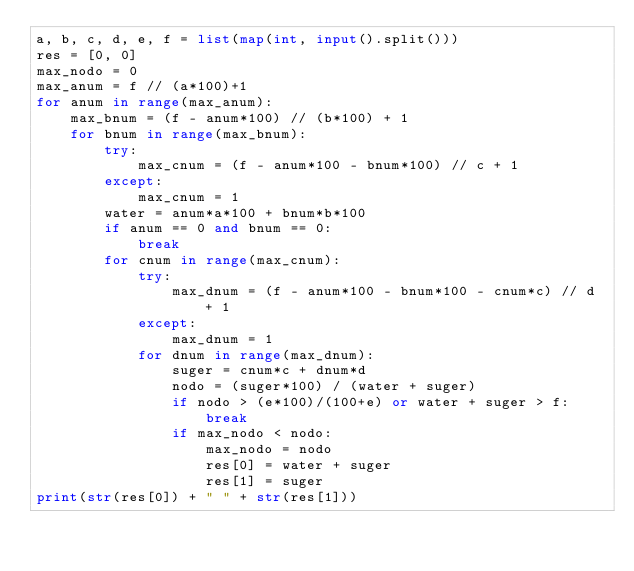Convert code to text. <code><loc_0><loc_0><loc_500><loc_500><_Python_>a, b, c, d, e, f = list(map(int, input().split()))
res = [0, 0]
max_nodo = 0
max_anum = f // (a*100)+1
for anum in range(max_anum):
    max_bnum = (f - anum*100) // (b*100) + 1
    for bnum in range(max_bnum):
        try:
            max_cnum = (f - anum*100 - bnum*100) // c + 1
        except:
            max_cnum = 1
        water = anum*a*100 + bnum*b*100
        if anum == 0 and bnum == 0:
            break
        for cnum in range(max_cnum):
            try:
                max_dnum = (f - anum*100 - bnum*100 - cnum*c) // d + 1
            except:
                max_dnum = 1
            for dnum in range(max_dnum):
                suger = cnum*c + dnum*d
                nodo = (suger*100) / (water + suger)
                if nodo > (e*100)/(100+e) or water + suger > f:
                    break
                if max_nodo < nodo:
                    max_nodo = nodo
                    res[0] = water + suger
                    res[1] = suger
print(str(res[0]) + " " + str(res[1]))</code> 